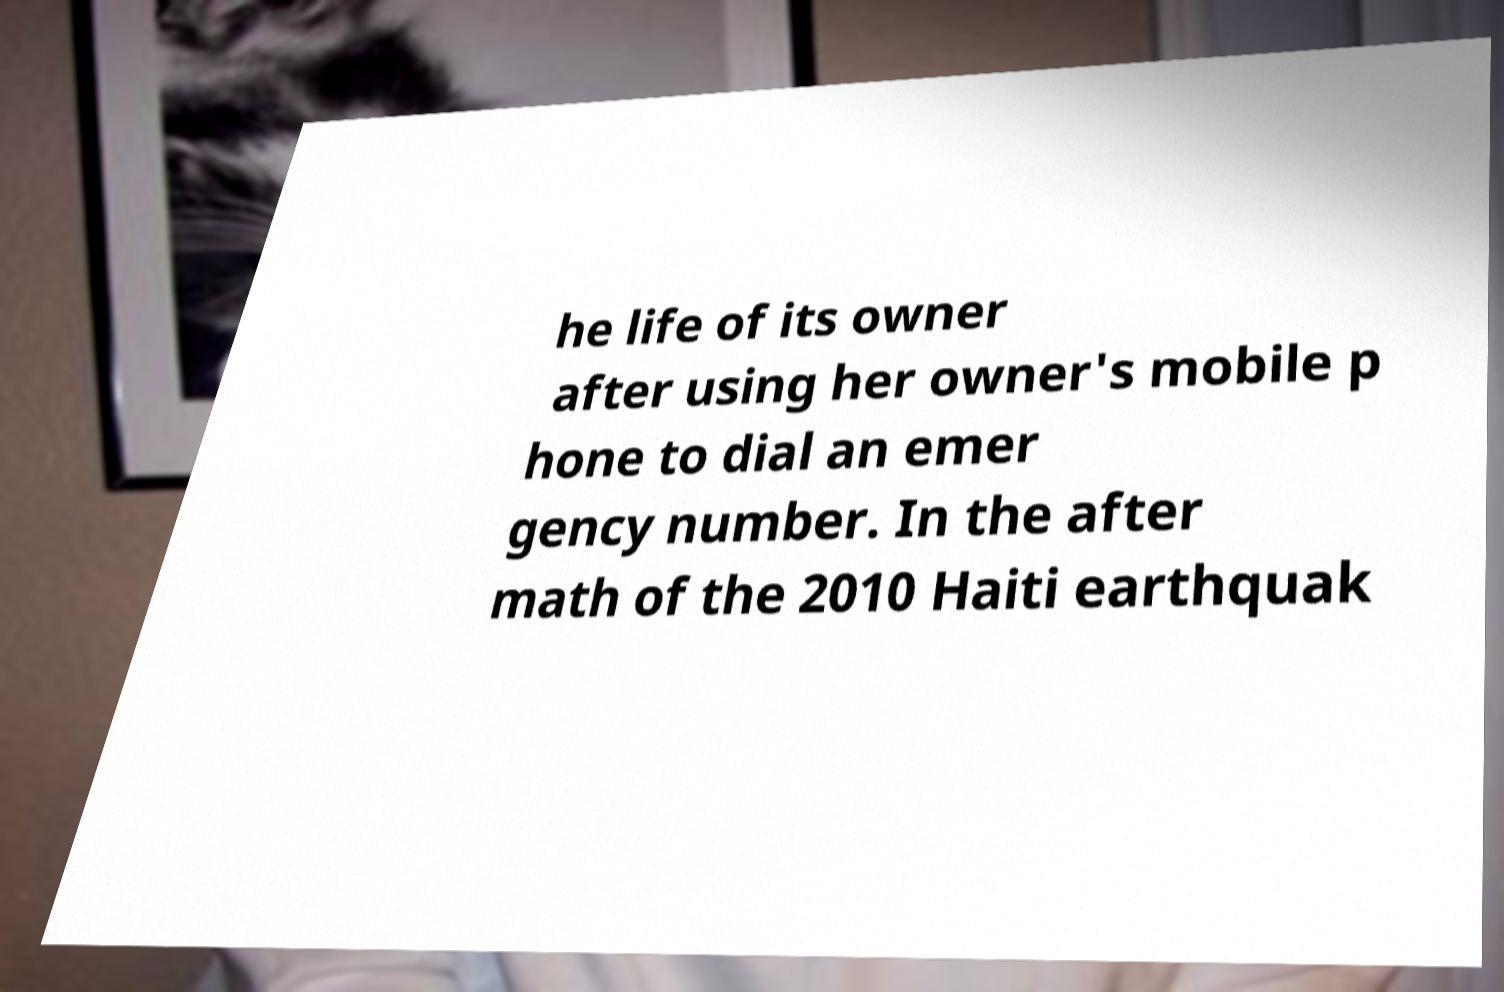Can you accurately transcribe the text from the provided image for me? he life of its owner after using her owner's mobile p hone to dial an emer gency number. In the after math of the 2010 Haiti earthquak 